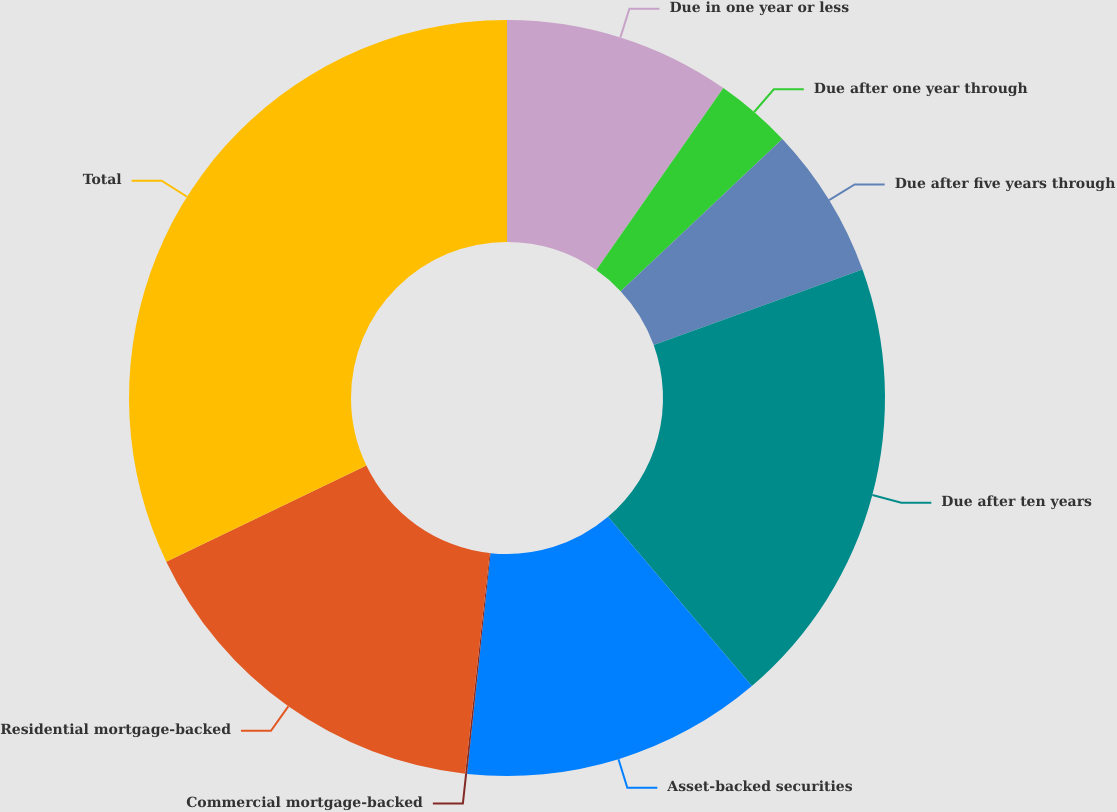Convert chart to OTSL. <chart><loc_0><loc_0><loc_500><loc_500><pie_chart><fcel>Due in one year or less<fcel>Due after one year through<fcel>Due after five years through<fcel>Due after ten years<fcel>Asset-backed securities<fcel>Commercial mortgage-backed<fcel>Residential mortgage-backed<fcel>Total<nl><fcel>9.7%<fcel>3.29%<fcel>6.49%<fcel>19.31%<fcel>12.9%<fcel>0.08%<fcel>16.11%<fcel>32.13%<nl></chart> 